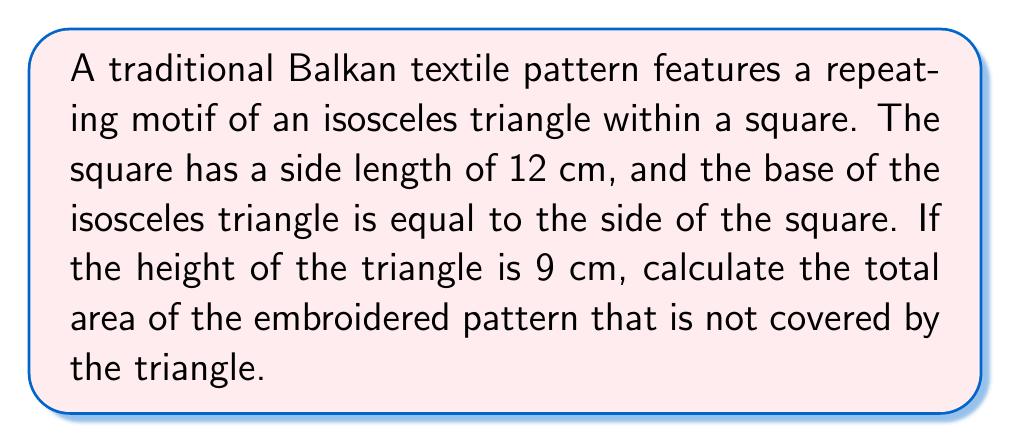Teach me how to tackle this problem. Let's approach this step-by-step:

1. Calculate the area of the square:
   $$A_{square} = s^2 = 12^2 = 144 \text{ cm}^2$$

2. Calculate the area of the isosceles triangle:
   The base (b) of the triangle is equal to the side of the square, so b = 12 cm.
   The height (h) is given as 9 cm.
   $$A_{triangle} = \frac{1}{2} \times b \times h = \frac{1}{2} \times 12 \times 9 = 54 \text{ cm}^2$$

3. Calculate the area not covered by the triangle:
   $$A_{not covered} = A_{square} - A_{triangle} = 144 - 54 = 90 \text{ cm}^2$$

[asy]
size(100);
fill((0,0)--(12,0)--(12,12)--(0,12)--cycle,lightgray);
fill((0,0)--(12,0)--(6,9)--cycle,white);
draw((0,0)--(12,0)--(12,12)--(0,12)--cycle);
draw((0,0)--(12,0)--(6,9)--cycle);
label("12 cm", (6,-0.5), S);
label("9 cm", (6.5,4.5), E);
label("12 cm", (12.5,6), E);
[/asy]
Answer: $90 \text{ cm}^2$ 